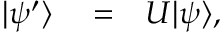<formula> <loc_0><loc_0><loc_500><loc_500>\begin{array} { r l r } { | \psi ^ { \prime } \rangle } & = } & { U | \psi \rangle , } \end{array}</formula> 